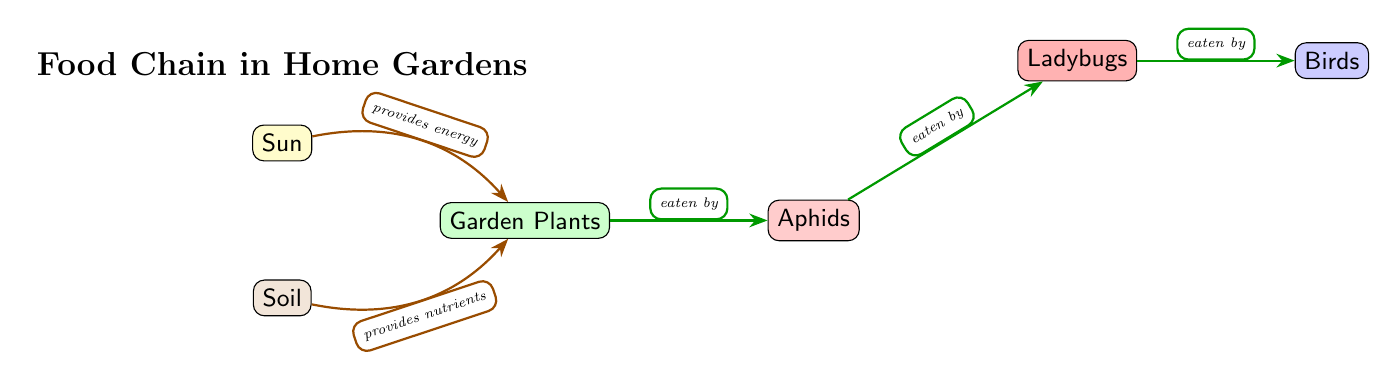What is the main source of energy in the food chain? The diagram shows the Sun as the first node, connected to the Garden Plants with a designated role of providing energy.
Answer: Sun How many levels of organisms are depicted in the food chain? The diagram presents a sequence of organisms starting from the Sun, leading to Garden Plants, then to Aphids, followed by Ladybugs, and finally Birds. This totals five distinct levels.
Answer: 5 What do garden plants rely on from the soil? The arrow from Soil to Garden Plants indicates that Soil provides nutrients to support the growth of garden plants.
Answer: Nutrients Which insect is at the second level of the food chain? The food chain includes Garden Plants as the first level, and the next organism directly connected to it is the Aphid, which occupies the second level.
Answer: Aphid What is the flow of energy from aphids to ladybugs called? In the diagram, the connection between Aphids and Ladybugs indicates that Aphids are consumed by Ladybugs, which is referred to as a food relationship.
Answer: Eaten by Which organism is at the top of the food chain depicted in the diagram? The last node in the food chain is Birds, which means it is the top predator in this specific ecosystem represented in the diagram.
Answer: Birds How many direct connections (edges) are there in the food chain? The diagram includes direct connections such as Sun to Garden Plants, Soil to Garden Plants, Garden Plants to Aphids, Aphids to Ladybugs, and Ladybugs to Birds, leading to a total of four connections.
Answer: 4 What role do ladybugs have in the food chain? Ladybugs are depicted in the diagram as a consumer; specifically, they eat aphids, meaning they serve as a predator of the second-level consumer within the garden food chain.
Answer: Eaten by What do garden plants receive from the sun? The arrow illustrates that Garden Plants receive energy from the Sun, which aids in their growth and photosynthesis processes.
Answer: Energy 